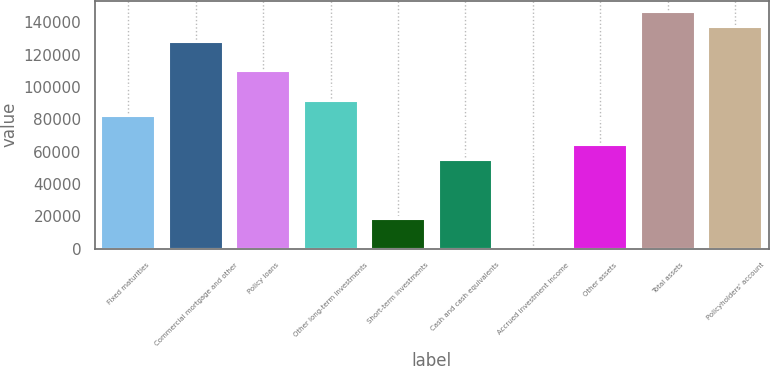Convert chart to OTSL. <chart><loc_0><loc_0><loc_500><loc_500><bar_chart><fcel>Fixed maturities<fcel>Commercial mortgage and other<fcel>Policy loans<fcel>Other long-term investments<fcel>Short-term investments<fcel>Cash and cash equivalents<fcel>Accrued investment income<fcel>Other assets<fcel>Total assets<fcel>Policyholders' account<nl><fcel>82216.9<fcel>127893<fcel>109622<fcel>91352<fcel>18271.1<fcel>54811.6<fcel>0.84<fcel>63946.7<fcel>146163<fcel>137028<nl></chart> 